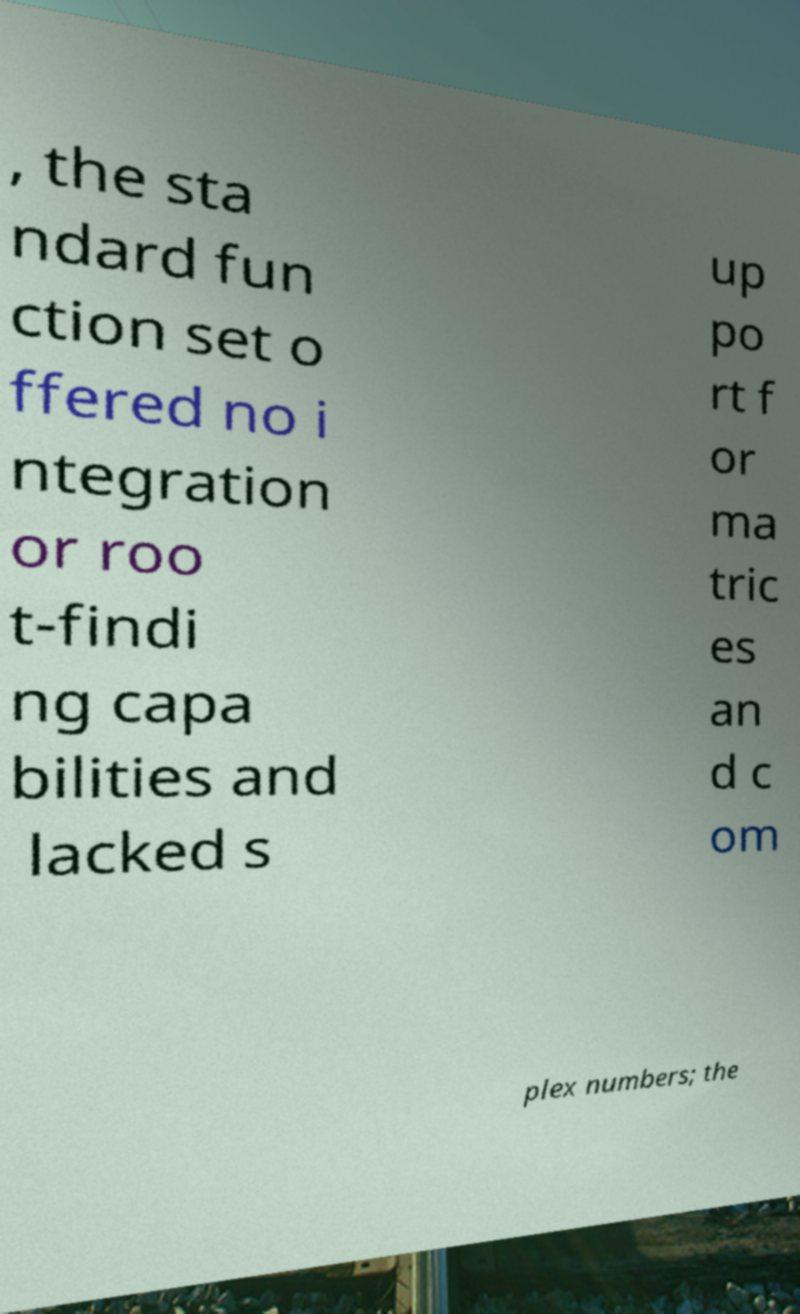What messages or text are displayed in this image? I need them in a readable, typed format. , the sta ndard fun ction set o ffered no i ntegration or roo t-findi ng capa bilities and lacked s up po rt f or ma tric es an d c om plex numbers; the 